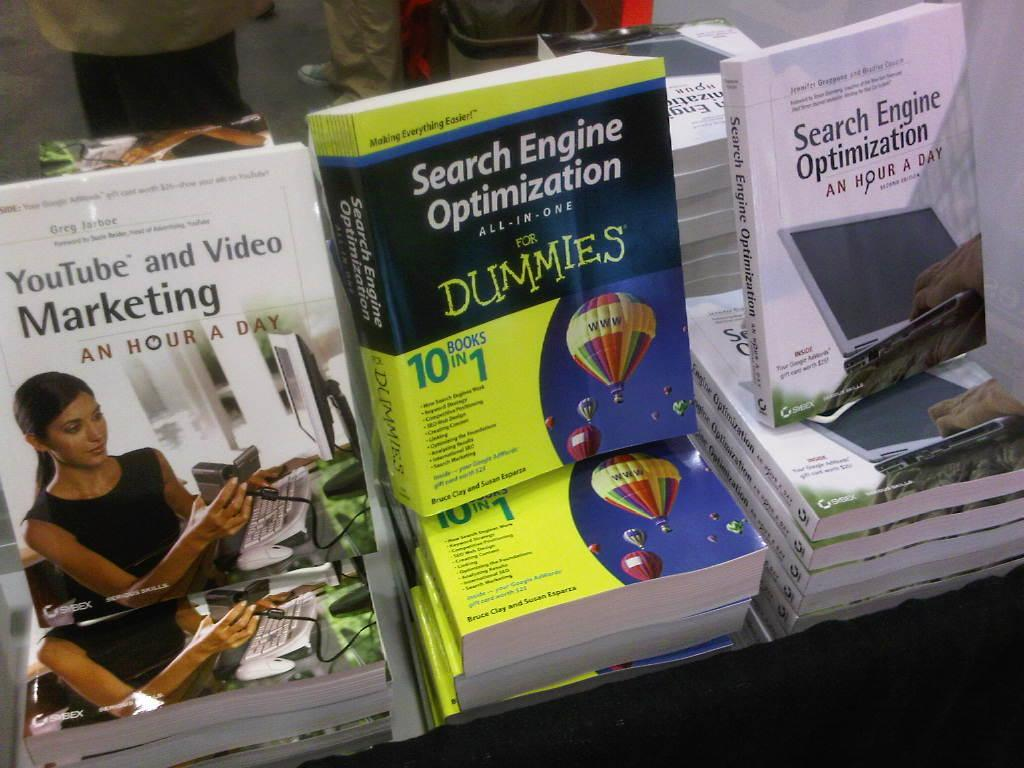Provide a one-sentence caption for the provided image. A couple of books about Search Engine Optimization are displayed. 